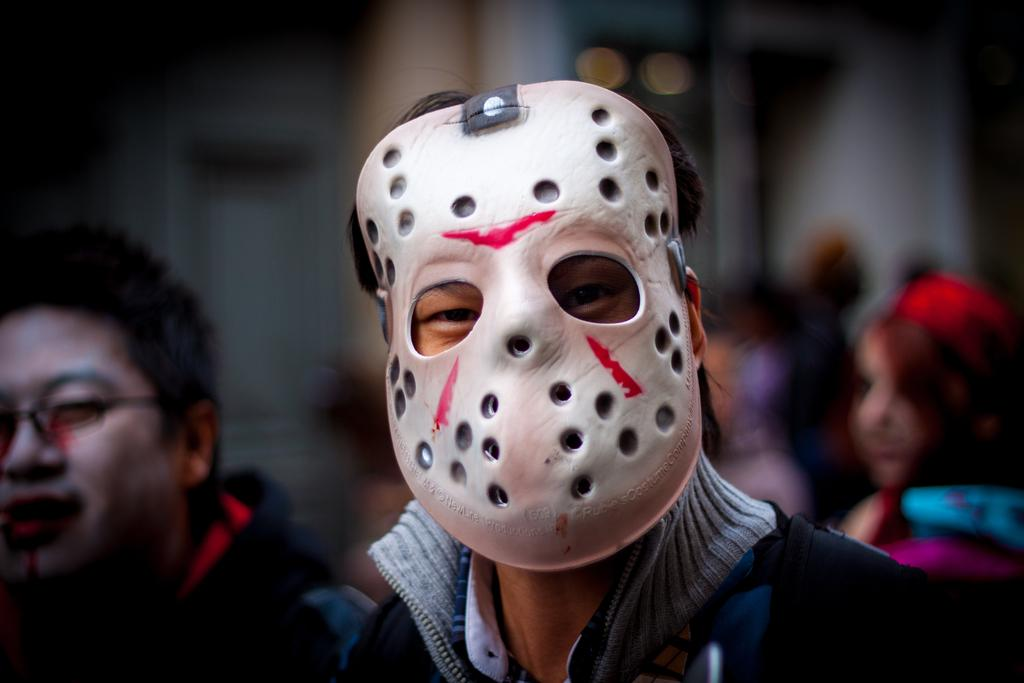How many people are in the image? There are people in the image, but the exact number is not specified. What is one person wearing in the image? One person is wearing a white-colored mask in the image. Can you describe the background of the image? The background of the image is blurry. What type of collar can be seen on the person's pet in the image? There is no pet or collar visible in the image. What thought is going through the person's mind in the image? The image does not provide any information about the person's thoughts. 